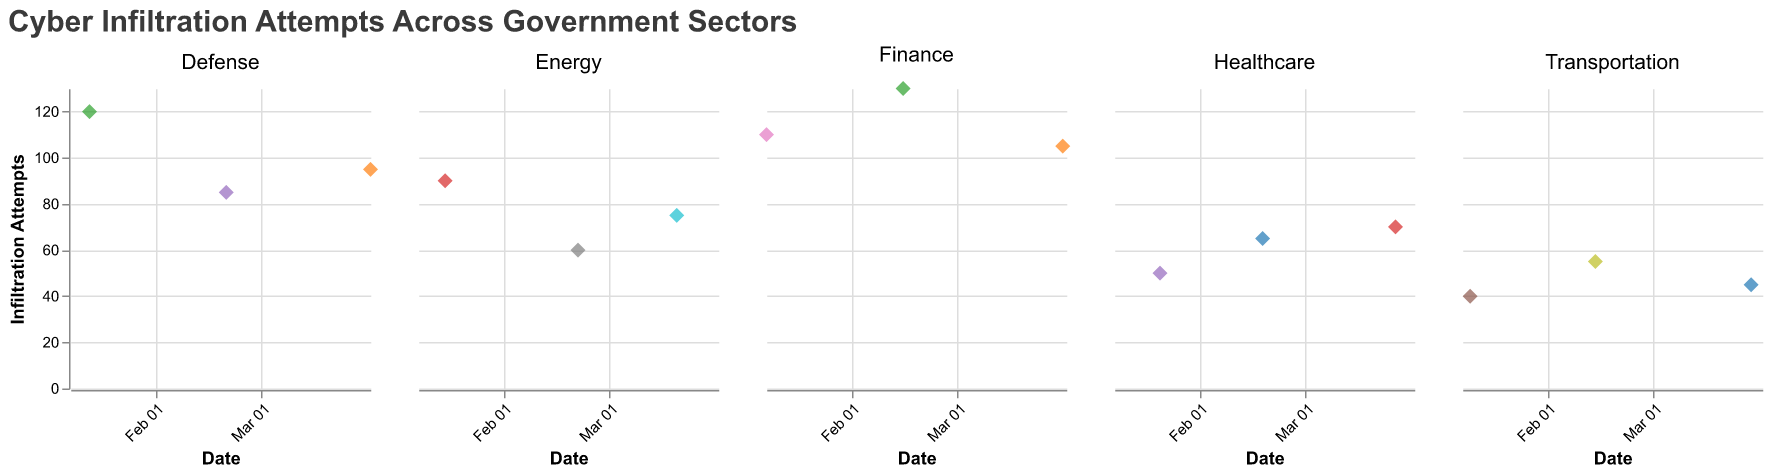How many organizations are in the Defense sector? The subplot for the Defense sector shows points with different colors, each representing a distinct organization. By counting the unique color points, we find the total number of organizations.
Answer: 3 Which organization had the highest number of cyber infiltration attempts in the Finance sector? Within the Finance sector subplot, compare the y-values (representing the number of infiltration attempts) of all organizations and identify the one with the highest point on the y-axis.
Answer: Internal Revenue Service Compare the number of infiltration attempts on January 15, 2023, between sectors. Which sector had the highest attempts? Examine the data points on January 15, 2023, across all subplots. Identify the sector whose point on this date has the highest y-value.
Answer: Defense What is the average number of infiltration attempts in the Healthcare sector? Add the infiltration attempts for all organizations in the Healthcare sector and divide by the number of organizations (3). (50 + 65 + 70) / 3 = 185 / 3
Answer: 61.7 On which date did the Transportation sector experience the highest number of cyber infiltration attempts? Look at the points in the Transportation sector subplot and identify the date corresponding to the highest y-value.
Answer: February 14, 2023 Which sector showed the least number of infiltration attempts overall in February 2023? Compare the infiltration attempts for all points in February 2023 across each sector, identifying the one with the lowest overall value.
Answer: Transportation How does the trend in the number of infiltration attempts in the Energy sector change over the dates shown? Analyze the points in the Energy sector subplot and observe the pattern along the x-axis (dates) and y-axis (infiltration attempts). The trend seems to show a decrease from January to February, followed by a slight increase in March.
Answer: Decrease and then increase In March 2023, which organization had the fewest infiltration attempts? Among the points in March 2023, find the one with the lowest y-value and identify the corresponding organization.
Answer: Federal Highway Administration Which month witnessed the peak infiltration attempts for the Department of the Treasury? Identify the highest point for the Department of the Treasury in the Finance sector subplot and note the corresponding date.
Answer: January Is there any sector that shows a consistent increase in infiltration attempts over the three-month period? Examine each sector's subplot to see if the y-values consistently rise from January to March. None of the sectors exhibit a strictly increasing trend across the months.
Answer: No 